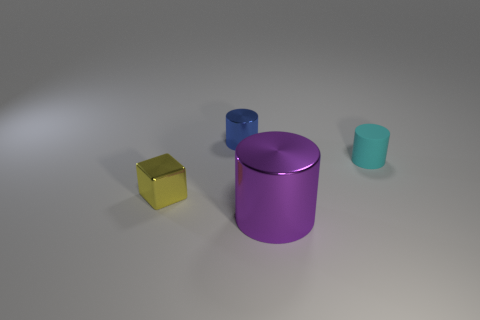Subtract all cyan cylinders. Subtract all red balls. How many cylinders are left? 2 Add 3 yellow balls. How many objects exist? 7 Subtract all cylinders. How many objects are left? 1 Add 2 small yellow objects. How many small yellow objects exist? 3 Subtract 0 cyan blocks. How many objects are left? 4 Subtract all red blocks. Subtract all purple cylinders. How many objects are left? 3 Add 1 small matte cylinders. How many small matte cylinders are left? 2 